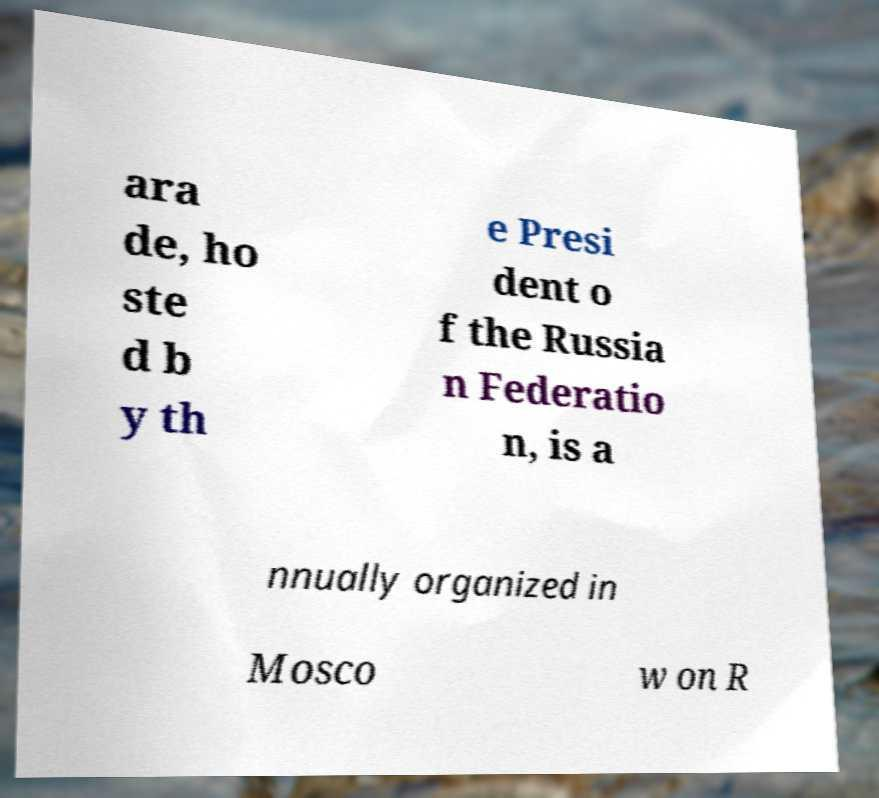Can you accurately transcribe the text from the provided image for me? ara de, ho ste d b y th e Presi dent o f the Russia n Federatio n, is a nnually organized in Mosco w on R 